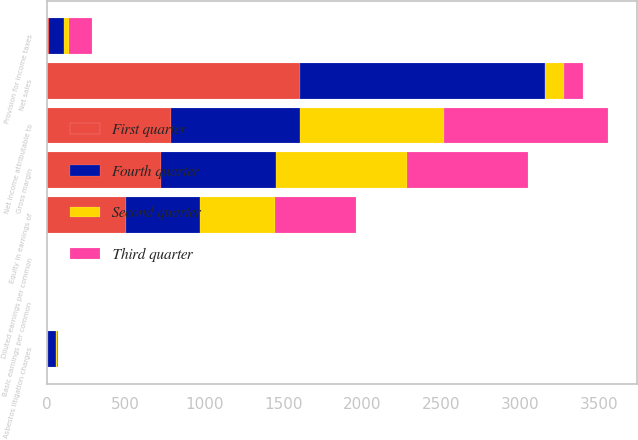Convert chart. <chart><loc_0><loc_0><loc_500><loc_500><stacked_bar_chart><ecel><fcel>Net sales<fcel>Gross margin<fcel>Asbestos litigation charges<fcel>Equity in earnings of<fcel>Provision for income taxes<fcel>Net income attributable to<fcel>Basic earnings per common<fcel>Diluted earnings per common<nl><fcel>Fourth quarter<fcel>1553<fcel>731<fcel>52<fcel>469<fcel>97<fcel>816<fcel>0.52<fcel>0.52<nl><fcel>Second quarter<fcel>121<fcel>827<fcel>5<fcel>474<fcel>31<fcel>913<fcel>0.59<fcel>0.58<nl><fcel>First quarter<fcel>1602<fcel>724<fcel>6<fcel>504<fcel>14<fcel>785<fcel>0.5<fcel>0.5<nl><fcel>Third quarter<fcel>121<fcel>767<fcel>8<fcel>511<fcel>145<fcel>1044<fcel>0.67<fcel>0.66<nl></chart> 